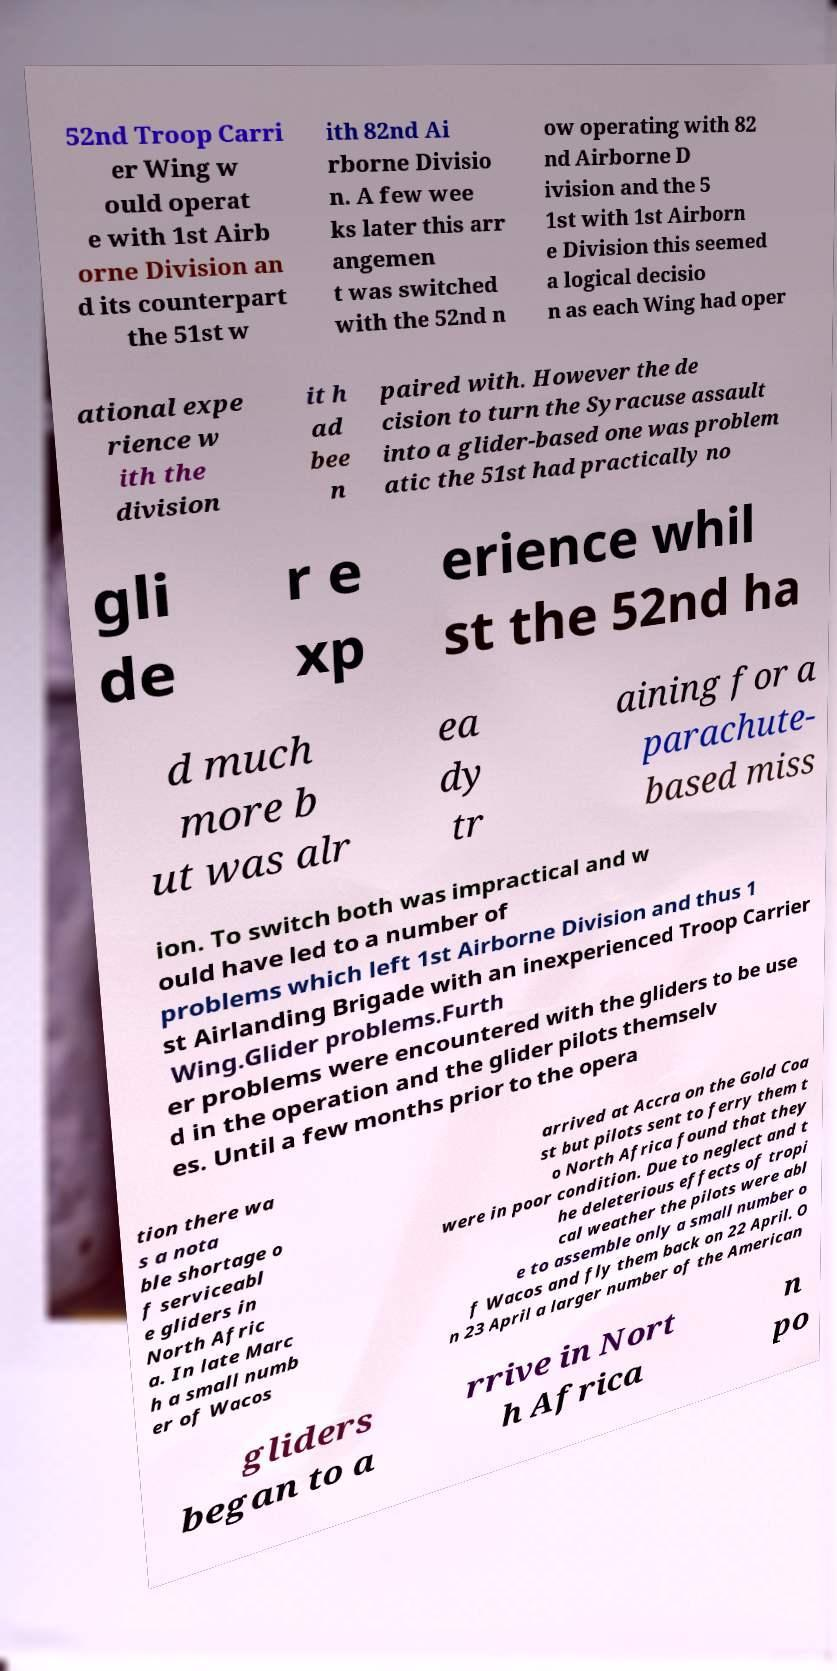What messages or text are displayed in this image? I need them in a readable, typed format. 52nd Troop Carri er Wing w ould operat e with 1st Airb orne Division an d its counterpart the 51st w ith 82nd Ai rborne Divisio n. A few wee ks later this arr angemen t was switched with the 52nd n ow operating with 82 nd Airborne D ivision and the 5 1st with 1st Airborn e Division this seemed a logical decisio n as each Wing had oper ational expe rience w ith the division it h ad bee n paired with. However the de cision to turn the Syracuse assault into a glider-based one was problem atic the 51st had practically no gli de r e xp erience whil st the 52nd ha d much more b ut was alr ea dy tr aining for a parachute- based miss ion. To switch both was impractical and w ould have led to a number of problems which left 1st Airborne Division and thus 1 st Airlanding Brigade with an inexperienced Troop Carrier Wing.Glider problems.Furth er problems were encountered with the gliders to be use d in the operation and the glider pilots themselv es. Until a few months prior to the opera tion there wa s a nota ble shortage o f serviceabl e gliders in North Afric a. In late Marc h a small numb er of Wacos arrived at Accra on the Gold Coa st but pilots sent to ferry them t o North Africa found that they were in poor condition. Due to neglect and t he deleterious effects of tropi cal weather the pilots were abl e to assemble only a small number o f Wacos and fly them back on 22 April. O n 23 April a larger number of the American gliders began to a rrive in Nort h Africa n po 